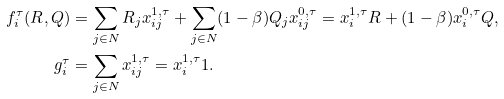<formula> <loc_0><loc_0><loc_500><loc_500>f _ { i } ^ { \tau } ( R , Q ) & = \sum _ { j \in N } R _ { j } x _ { i j } ^ { 1 , \tau } + \sum _ { j \in N } ( 1 - \beta ) Q _ { j } x _ { i j } ^ { 0 , \tau } = x _ { i } ^ { 1 , \tau } R + ( 1 - \beta ) x _ { i } ^ { 0 , \tau } Q , \\ g _ { i } ^ { \tau } & = \sum _ { j \in N } x _ { i j } ^ { 1 , \tau } = x _ { i } ^ { 1 , \tau } 1 .</formula> 